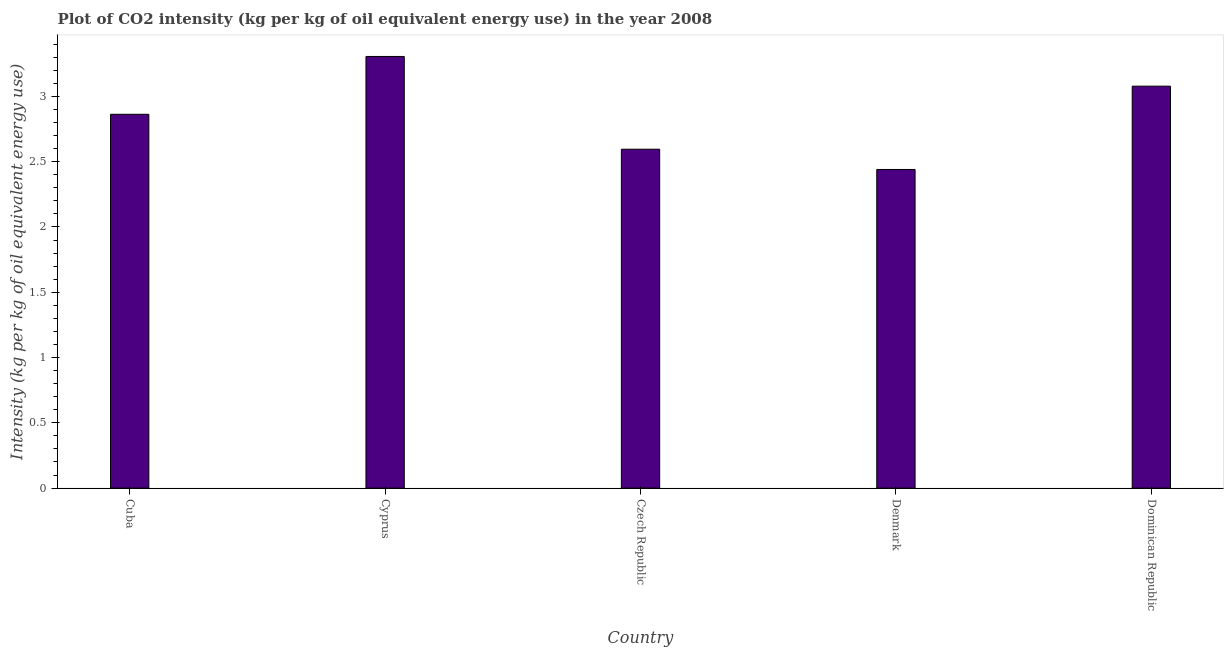Does the graph contain grids?
Your answer should be very brief. No. What is the title of the graph?
Your answer should be very brief. Plot of CO2 intensity (kg per kg of oil equivalent energy use) in the year 2008. What is the label or title of the Y-axis?
Ensure brevity in your answer.  Intensity (kg per kg of oil equivalent energy use). What is the co2 intensity in Dominican Republic?
Ensure brevity in your answer.  3.08. Across all countries, what is the maximum co2 intensity?
Make the answer very short. 3.31. Across all countries, what is the minimum co2 intensity?
Offer a very short reply. 2.44. In which country was the co2 intensity maximum?
Make the answer very short. Cyprus. What is the sum of the co2 intensity?
Ensure brevity in your answer.  14.28. What is the difference between the co2 intensity in Cyprus and Czech Republic?
Give a very brief answer. 0.71. What is the average co2 intensity per country?
Ensure brevity in your answer.  2.86. What is the median co2 intensity?
Give a very brief answer. 2.86. In how many countries, is the co2 intensity greater than 3 kg?
Provide a succinct answer. 2. What is the ratio of the co2 intensity in Cyprus to that in Czech Republic?
Provide a short and direct response. 1.27. Is the co2 intensity in Cyprus less than that in Czech Republic?
Your answer should be very brief. No. What is the difference between the highest and the second highest co2 intensity?
Keep it short and to the point. 0.23. Is the sum of the co2 intensity in Cyprus and Denmark greater than the maximum co2 intensity across all countries?
Offer a terse response. Yes. What is the difference between the highest and the lowest co2 intensity?
Provide a succinct answer. 0.87. How many bars are there?
Your answer should be very brief. 5. What is the Intensity (kg per kg of oil equivalent energy use) of Cuba?
Ensure brevity in your answer.  2.86. What is the Intensity (kg per kg of oil equivalent energy use) in Cyprus?
Ensure brevity in your answer.  3.31. What is the Intensity (kg per kg of oil equivalent energy use) in Czech Republic?
Provide a short and direct response. 2.6. What is the Intensity (kg per kg of oil equivalent energy use) in Denmark?
Make the answer very short. 2.44. What is the Intensity (kg per kg of oil equivalent energy use) of Dominican Republic?
Offer a very short reply. 3.08. What is the difference between the Intensity (kg per kg of oil equivalent energy use) in Cuba and Cyprus?
Offer a very short reply. -0.44. What is the difference between the Intensity (kg per kg of oil equivalent energy use) in Cuba and Czech Republic?
Keep it short and to the point. 0.27. What is the difference between the Intensity (kg per kg of oil equivalent energy use) in Cuba and Denmark?
Make the answer very short. 0.42. What is the difference between the Intensity (kg per kg of oil equivalent energy use) in Cuba and Dominican Republic?
Offer a terse response. -0.22. What is the difference between the Intensity (kg per kg of oil equivalent energy use) in Cyprus and Czech Republic?
Offer a very short reply. 0.71. What is the difference between the Intensity (kg per kg of oil equivalent energy use) in Cyprus and Denmark?
Offer a terse response. 0.87. What is the difference between the Intensity (kg per kg of oil equivalent energy use) in Cyprus and Dominican Republic?
Make the answer very short. 0.23. What is the difference between the Intensity (kg per kg of oil equivalent energy use) in Czech Republic and Denmark?
Keep it short and to the point. 0.16. What is the difference between the Intensity (kg per kg of oil equivalent energy use) in Czech Republic and Dominican Republic?
Keep it short and to the point. -0.48. What is the difference between the Intensity (kg per kg of oil equivalent energy use) in Denmark and Dominican Republic?
Offer a terse response. -0.64. What is the ratio of the Intensity (kg per kg of oil equivalent energy use) in Cuba to that in Cyprus?
Your response must be concise. 0.87. What is the ratio of the Intensity (kg per kg of oil equivalent energy use) in Cuba to that in Czech Republic?
Offer a terse response. 1.1. What is the ratio of the Intensity (kg per kg of oil equivalent energy use) in Cuba to that in Denmark?
Your answer should be very brief. 1.17. What is the ratio of the Intensity (kg per kg of oil equivalent energy use) in Cuba to that in Dominican Republic?
Make the answer very short. 0.93. What is the ratio of the Intensity (kg per kg of oil equivalent energy use) in Cyprus to that in Czech Republic?
Your answer should be compact. 1.27. What is the ratio of the Intensity (kg per kg of oil equivalent energy use) in Cyprus to that in Denmark?
Give a very brief answer. 1.35. What is the ratio of the Intensity (kg per kg of oil equivalent energy use) in Cyprus to that in Dominican Republic?
Your answer should be compact. 1.07. What is the ratio of the Intensity (kg per kg of oil equivalent energy use) in Czech Republic to that in Denmark?
Provide a short and direct response. 1.06. What is the ratio of the Intensity (kg per kg of oil equivalent energy use) in Czech Republic to that in Dominican Republic?
Make the answer very short. 0.84. What is the ratio of the Intensity (kg per kg of oil equivalent energy use) in Denmark to that in Dominican Republic?
Offer a very short reply. 0.79. 